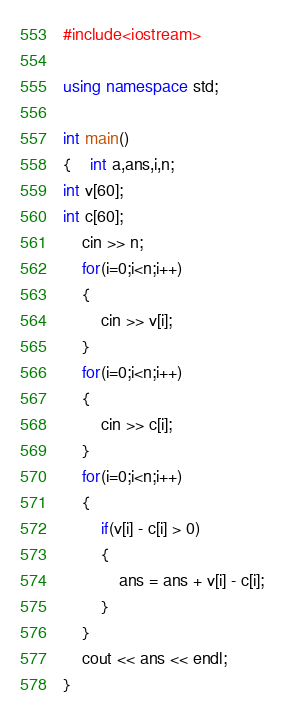<code> <loc_0><loc_0><loc_500><loc_500><_C++_>#include<iostream>

using namespace std;

int main()
{	int a,ans,i,n;
int v[60];
int c[60];
	cin >> n;
	for(i=0;i<n;i++)
	{
		cin >> v[i];
	}
	for(i=0;i<n;i++)
	{
		cin >> c[i];
	}
	for(i=0;i<n;i++)
	{
		if(v[i] - c[i] > 0)
		{
			ans = ans + v[i] - c[i];
		}
	}
	cout << ans << endl;
}</code> 